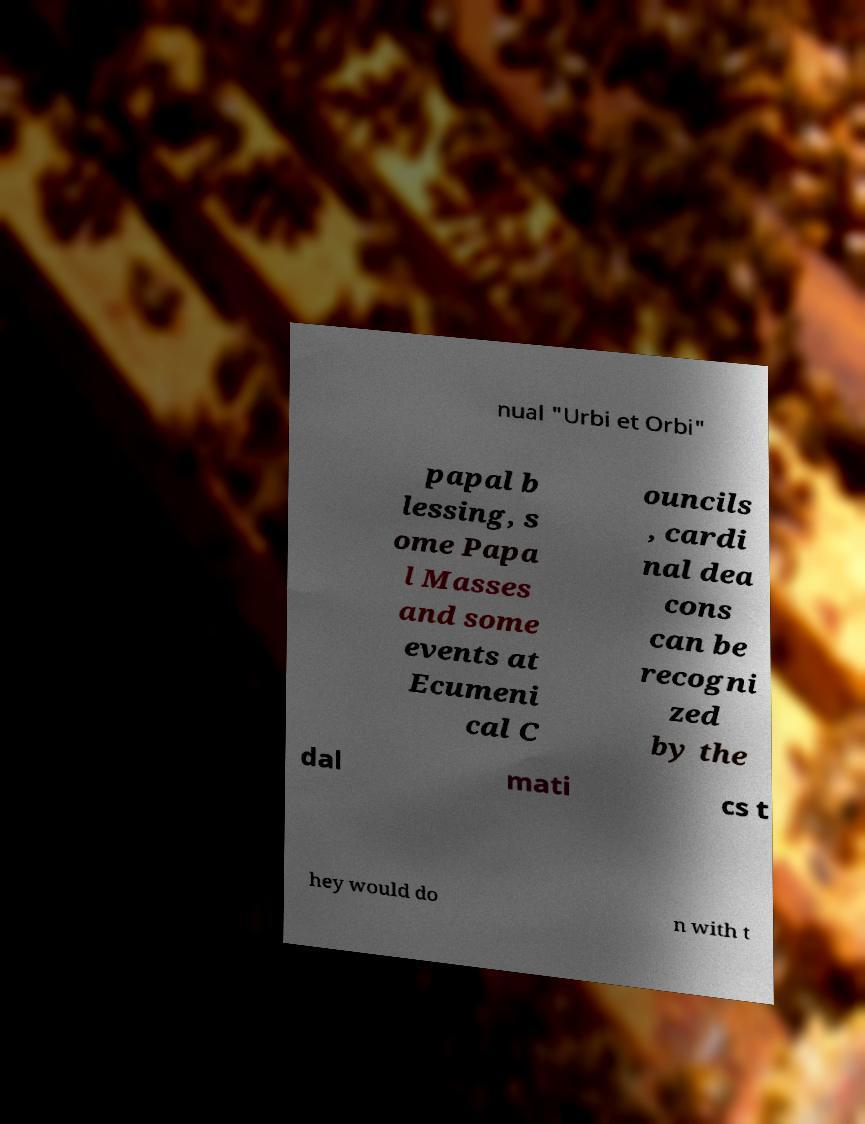Please read and relay the text visible in this image. What does it say? nual "Urbi et Orbi" papal b lessing, s ome Papa l Masses and some events at Ecumeni cal C ouncils , cardi nal dea cons can be recogni zed by the dal mati cs t hey would do n with t 